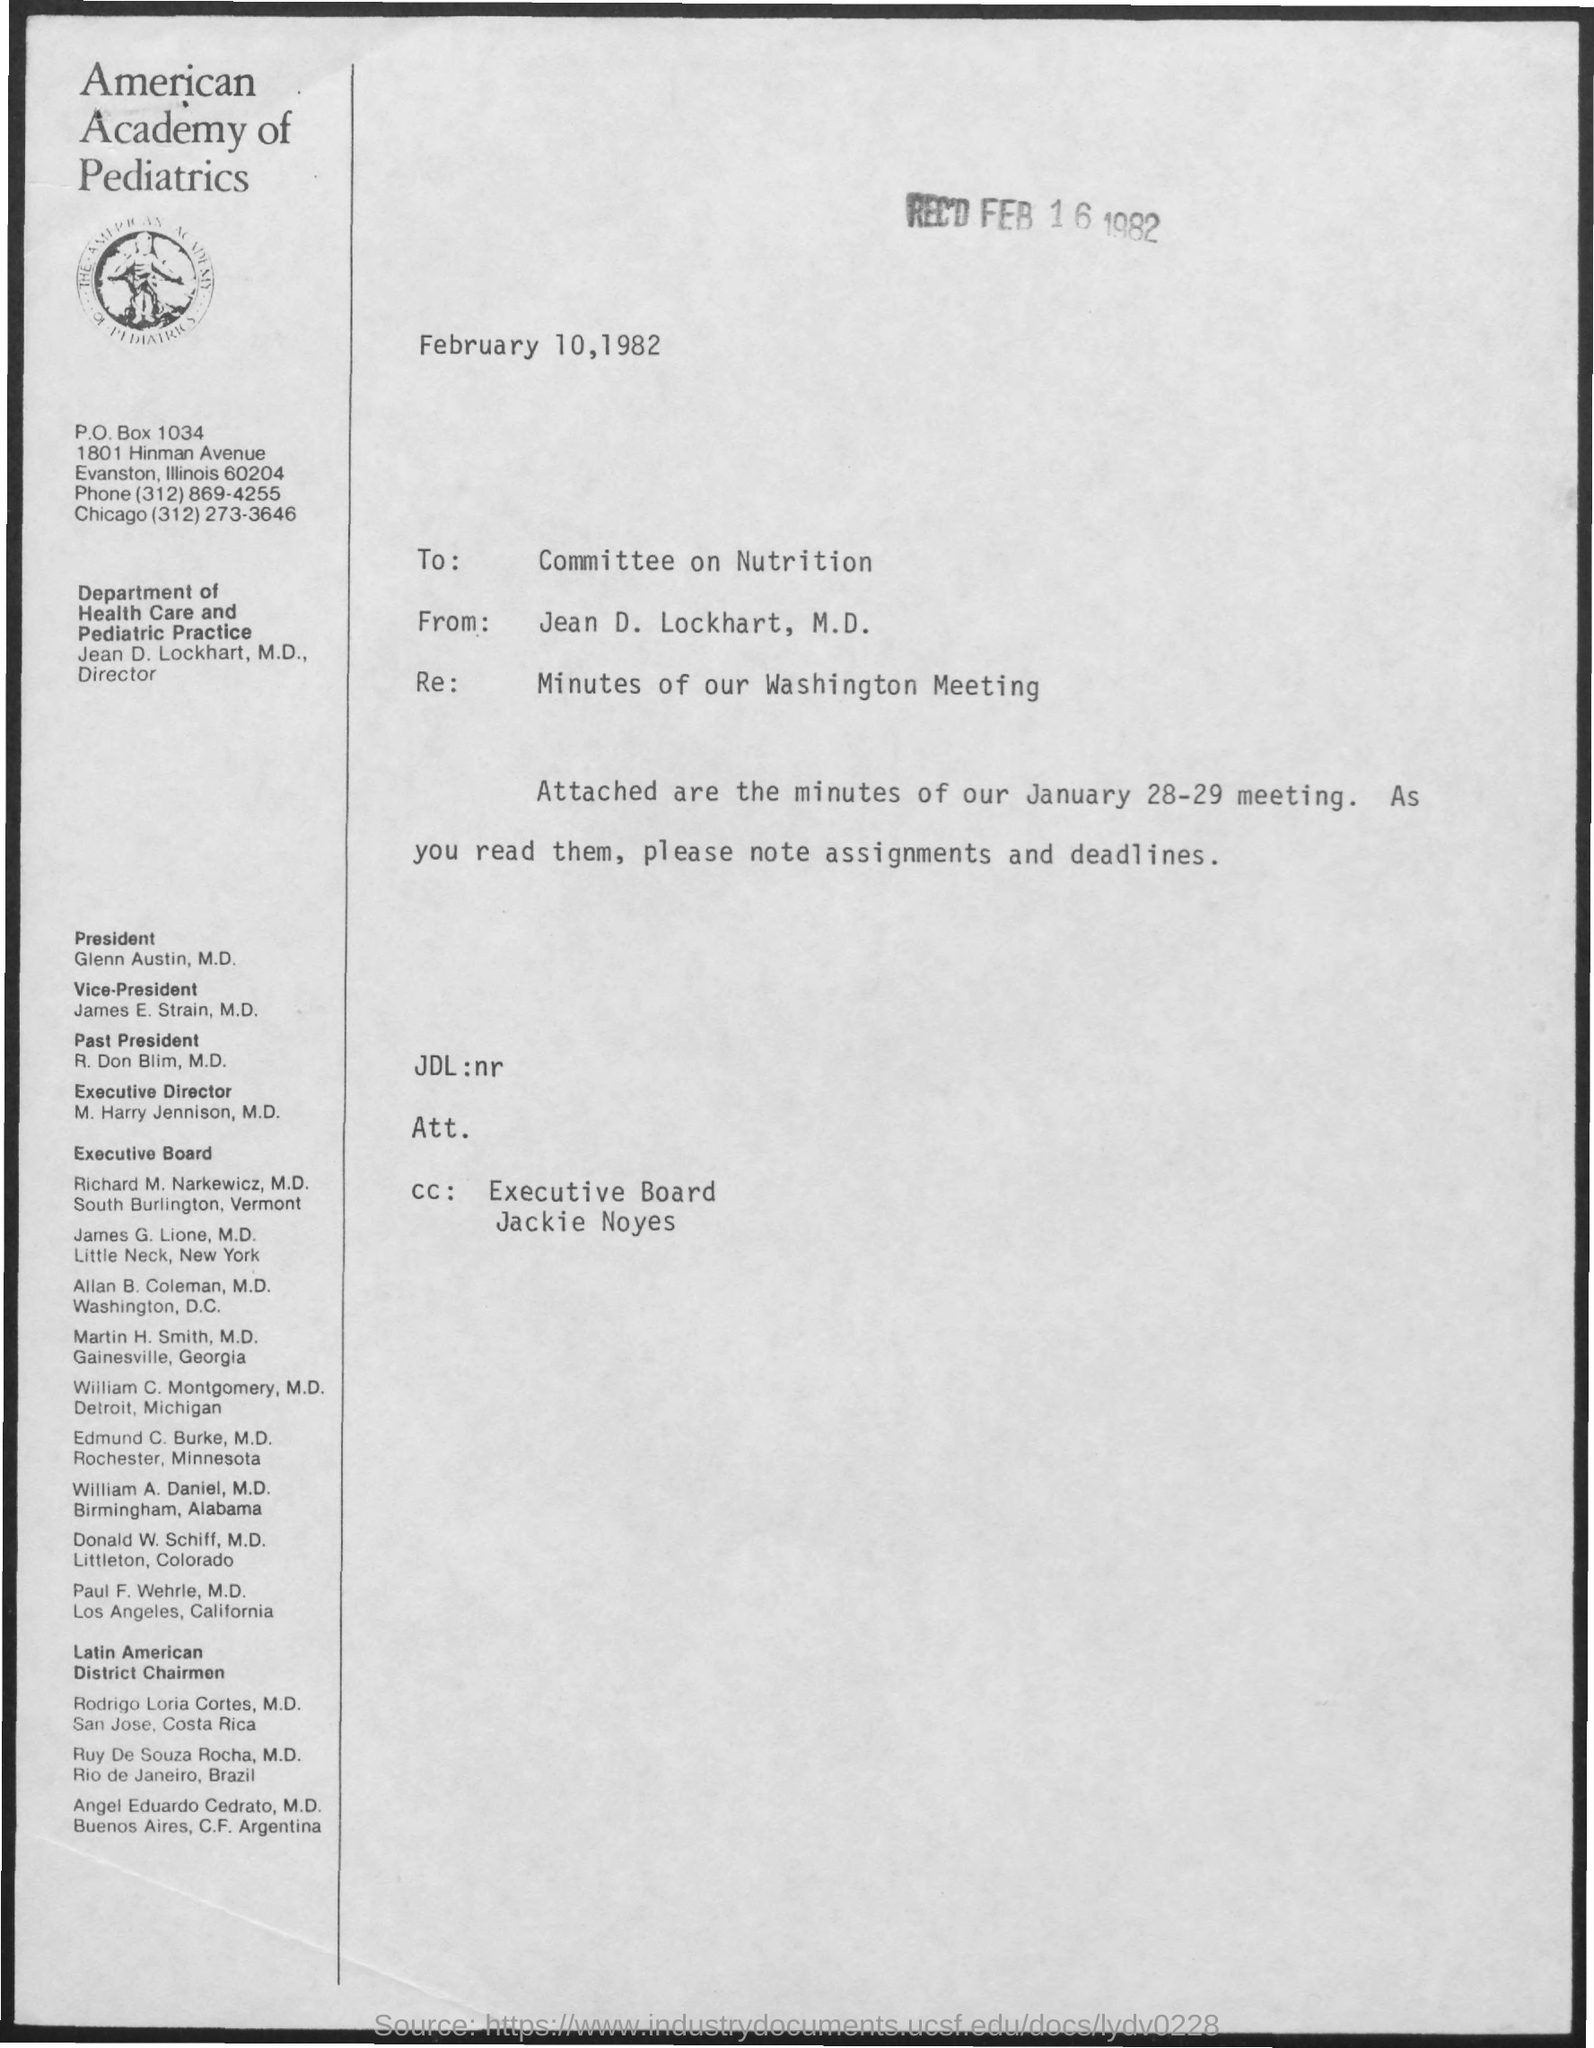Draw attention to some important aspects in this diagram. Jean D. Lockhart is the author of this letter. The Re: minutes of our Washington meeting are a documented record of the discussions and decisions made during the meeting, held in Washington. On February 16th, 1982, the date was recorded. The Committee on Nutrition is the recipient of the letter. 